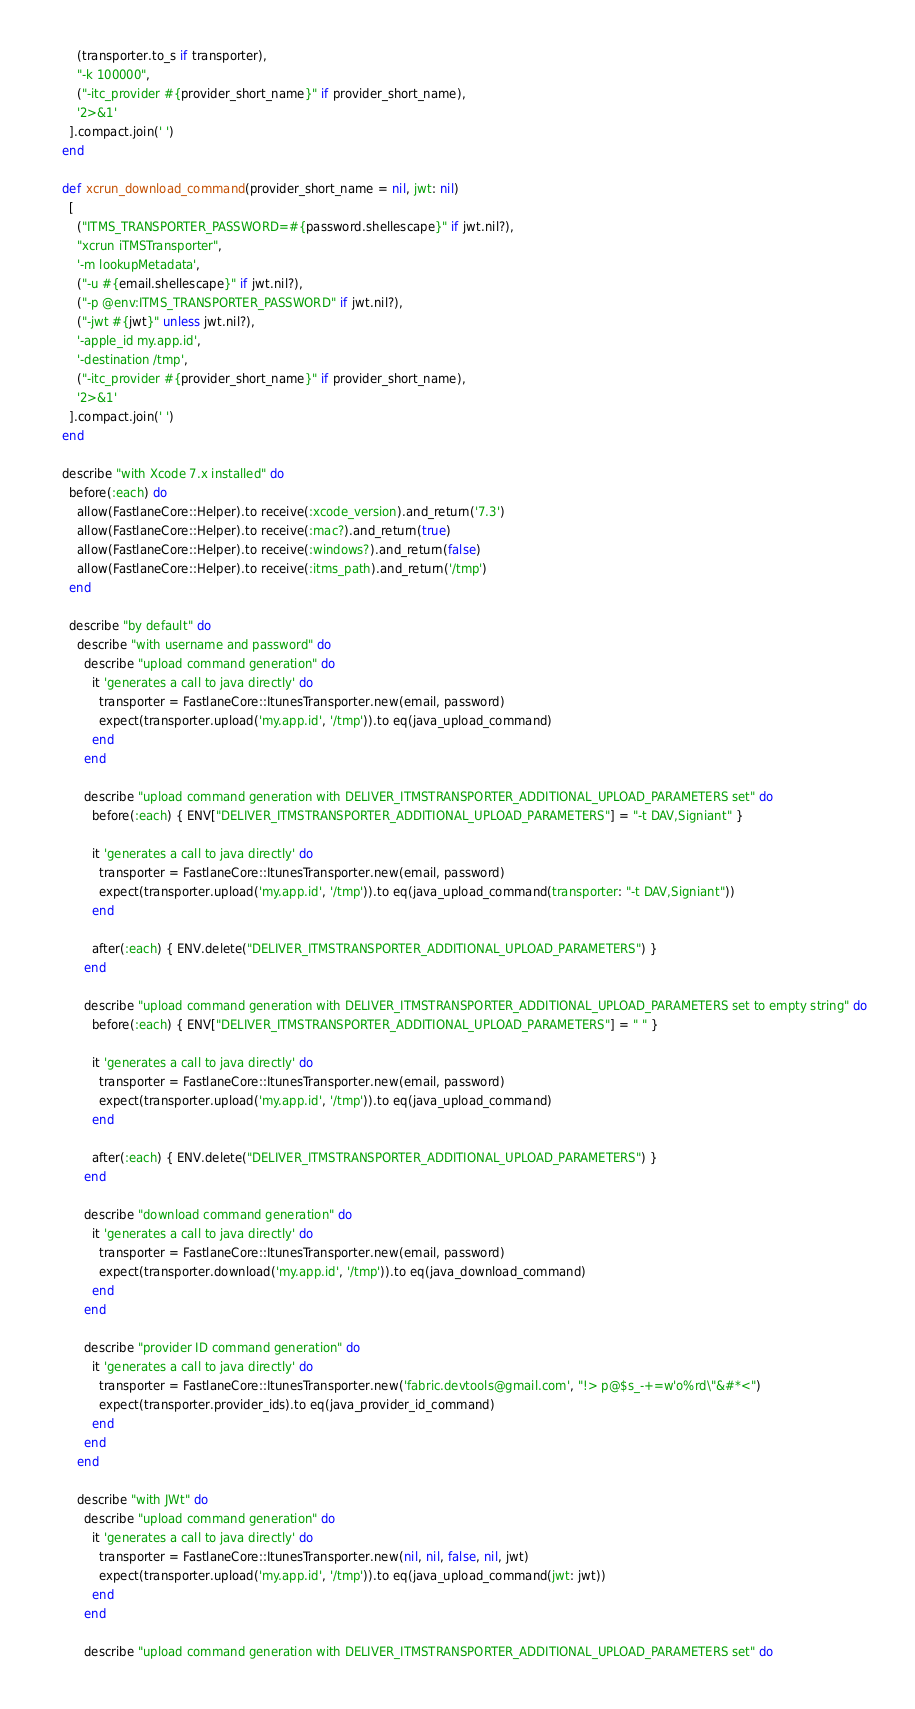<code> <loc_0><loc_0><loc_500><loc_500><_Ruby_>        (transporter.to_s if transporter),
        "-k 100000",
        ("-itc_provider #{provider_short_name}" if provider_short_name),
        '2>&1'
      ].compact.join(' ')
    end

    def xcrun_download_command(provider_short_name = nil, jwt: nil)
      [
        ("ITMS_TRANSPORTER_PASSWORD=#{password.shellescape}" if jwt.nil?),
        "xcrun iTMSTransporter",
        '-m lookupMetadata',
        ("-u #{email.shellescape}" if jwt.nil?),
        ("-p @env:ITMS_TRANSPORTER_PASSWORD" if jwt.nil?),
        ("-jwt #{jwt}" unless jwt.nil?),
        '-apple_id my.app.id',
        '-destination /tmp',
        ("-itc_provider #{provider_short_name}" if provider_short_name),
        '2>&1'
      ].compact.join(' ')
    end

    describe "with Xcode 7.x installed" do
      before(:each) do
        allow(FastlaneCore::Helper).to receive(:xcode_version).and_return('7.3')
        allow(FastlaneCore::Helper).to receive(:mac?).and_return(true)
        allow(FastlaneCore::Helper).to receive(:windows?).and_return(false)
        allow(FastlaneCore::Helper).to receive(:itms_path).and_return('/tmp')
      end

      describe "by default" do
        describe "with username and password" do
          describe "upload command generation" do
            it 'generates a call to java directly' do
              transporter = FastlaneCore::ItunesTransporter.new(email, password)
              expect(transporter.upload('my.app.id', '/tmp')).to eq(java_upload_command)
            end
          end

          describe "upload command generation with DELIVER_ITMSTRANSPORTER_ADDITIONAL_UPLOAD_PARAMETERS set" do
            before(:each) { ENV["DELIVER_ITMSTRANSPORTER_ADDITIONAL_UPLOAD_PARAMETERS"] = "-t DAV,Signiant" }

            it 'generates a call to java directly' do
              transporter = FastlaneCore::ItunesTransporter.new(email, password)
              expect(transporter.upload('my.app.id', '/tmp')).to eq(java_upload_command(transporter: "-t DAV,Signiant"))
            end

            after(:each) { ENV.delete("DELIVER_ITMSTRANSPORTER_ADDITIONAL_UPLOAD_PARAMETERS") }
          end

          describe "upload command generation with DELIVER_ITMSTRANSPORTER_ADDITIONAL_UPLOAD_PARAMETERS set to empty string" do
            before(:each) { ENV["DELIVER_ITMSTRANSPORTER_ADDITIONAL_UPLOAD_PARAMETERS"] = " " }

            it 'generates a call to java directly' do
              transporter = FastlaneCore::ItunesTransporter.new(email, password)
              expect(transporter.upload('my.app.id', '/tmp')).to eq(java_upload_command)
            end

            after(:each) { ENV.delete("DELIVER_ITMSTRANSPORTER_ADDITIONAL_UPLOAD_PARAMETERS") }
          end

          describe "download command generation" do
            it 'generates a call to java directly' do
              transporter = FastlaneCore::ItunesTransporter.new(email, password)
              expect(transporter.download('my.app.id', '/tmp')).to eq(java_download_command)
            end
          end

          describe "provider ID command generation" do
            it 'generates a call to java directly' do
              transporter = FastlaneCore::ItunesTransporter.new('fabric.devtools@gmail.com', "!> p@$s_-+=w'o%rd\"&#*<")
              expect(transporter.provider_ids).to eq(java_provider_id_command)
            end
          end
        end

        describe "with JWt" do
          describe "upload command generation" do
            it 'generates a call to java directly' do
              transporter = FastlaneCore::ItunesTransporter.new(nil, nil, false, nil, jwt)
              expect(transporter.upload('my.app.id', '/tmp')).to eq(java_upload_command(jwt: jwt))
            end
          end

          describe "upload command generation with DELIVER_ITMSTRANSPORTER_ADDITIONAL_UPLOAD_PARAMETERS set" do</code> 